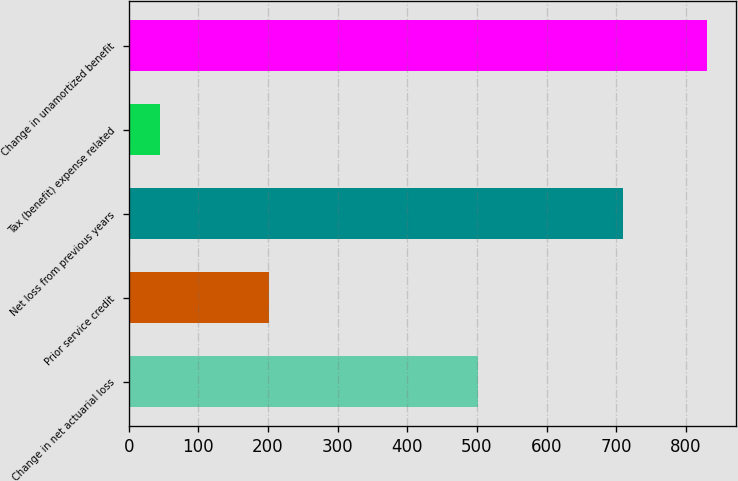<chart> <loc_0><loc_0><loc_500><loc_500><bar_chart><fcel>Change in net actuarial loss<fcel>Prior service credit<fcel>Net loss from previous years<fcel>Tax (benefit) expense related<fcel>Change in unamortized benefit<nl><fcel>501<fcel>202<fcel>709<fcel>45<fcel>830<nl></chart> 